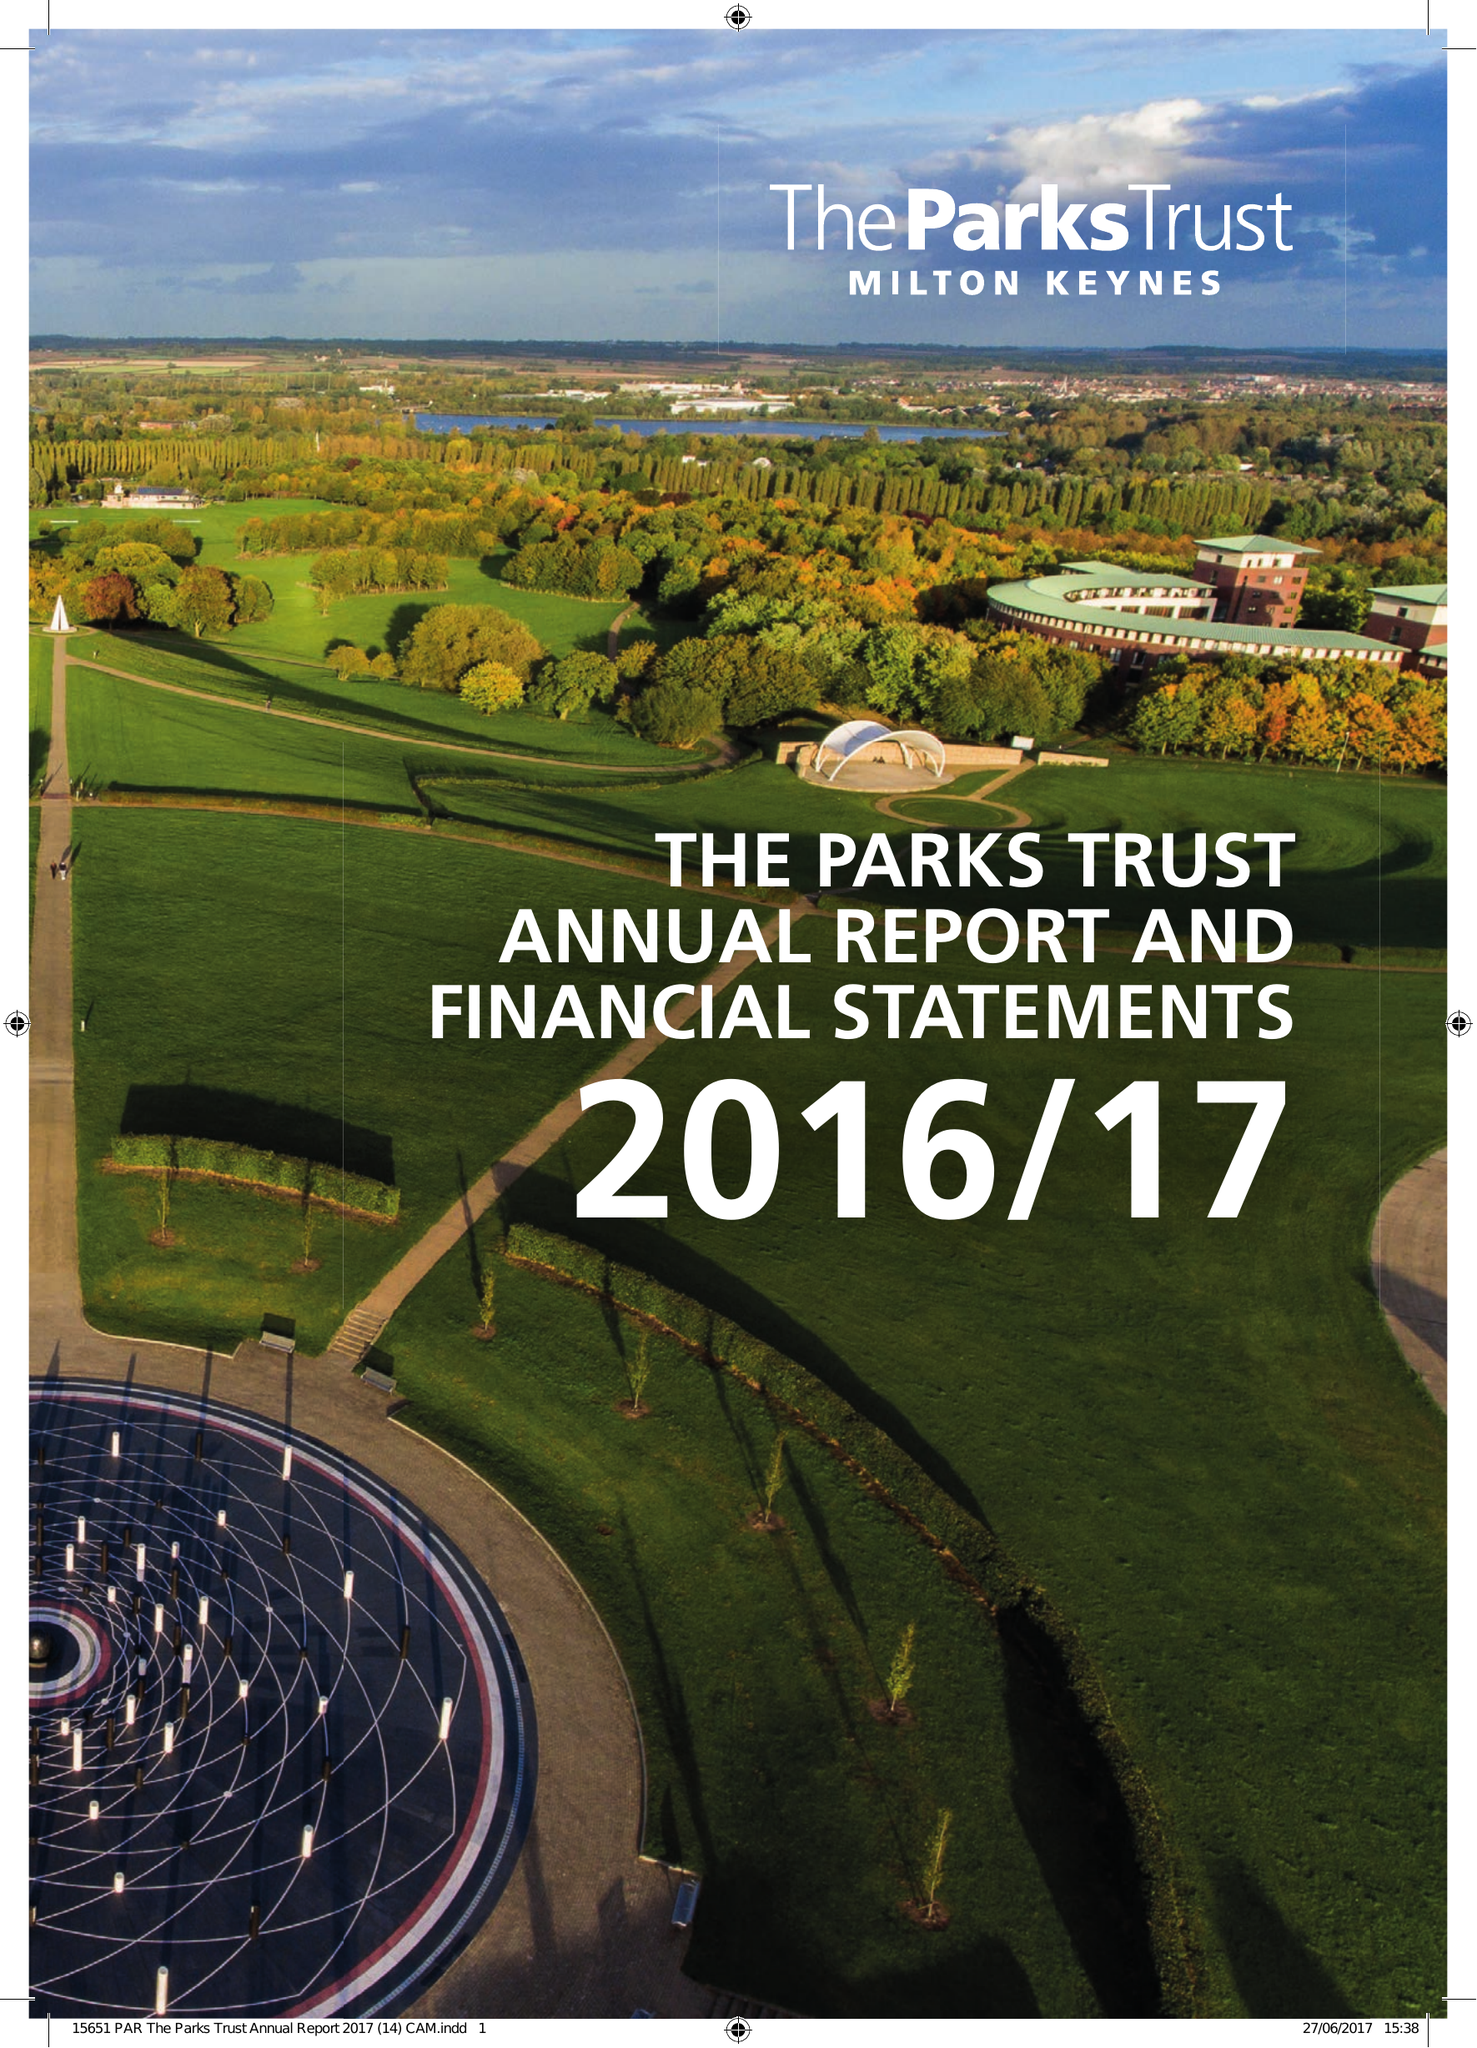What is the value for the charity_number?
Answer the question using a single word or phrase. 1007183 